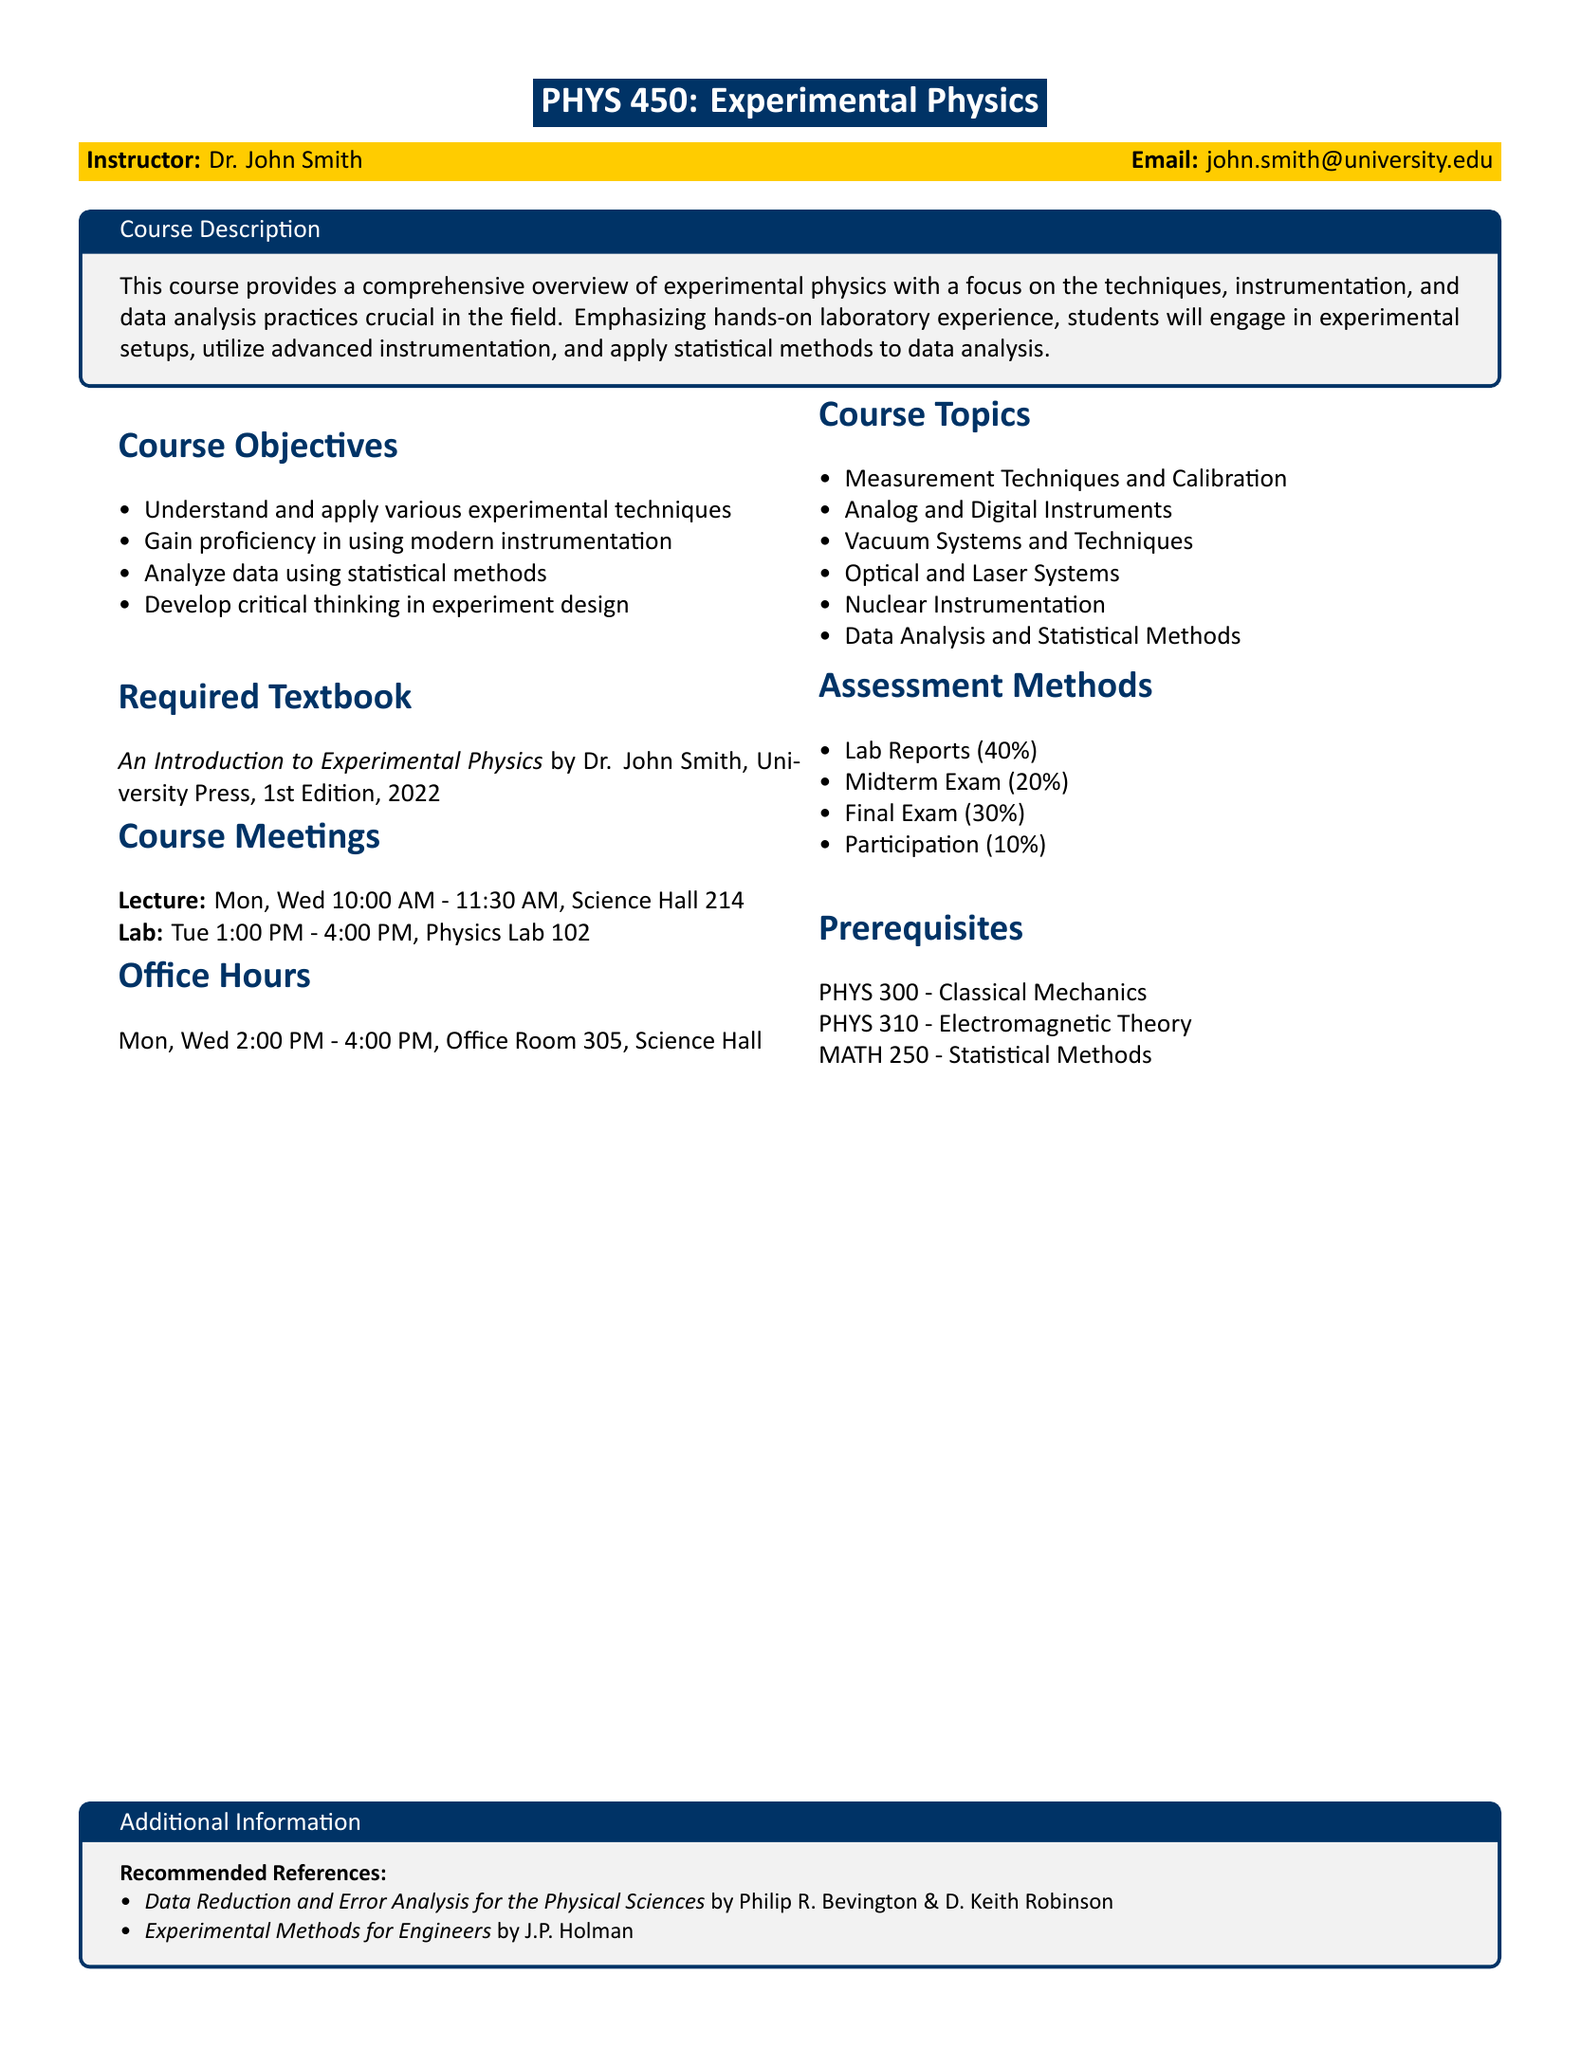What is the course code for Experimental Physics? The course code is stated at the top of the syllabus.
Answer: PHYS 450 Who is the instructor for the course? The instructor's name is provided in the syllabus.
Answer: Dr. John Smith What percentage of the assessment is allocated to lab reports? The distribution of assessment percentages is listed under Assessment Methods.
Answer: 40% On which days and at what time is the lecture scheduled? The schedule for the lecture is provided in the Course Meetings section.
Answer: Mon, Wed 10:00 AM - 11:30 AM What is the title of the required textbook? The name of the required textbook is mentioned in the Required Textbook section.
Answer: An Introduction to Experimental Physics How many hours per week are dedicated to lab sessions? The lab schedule is specified in the Course Meetings section, detailing the hours.
Answer: 3 hours What are the prerequisites for the course? The prerequisites are listed in the relevant section of the syllabus.
Answer: PHYS 300, PHYS 310, MATH 250 What is one of the recommended references for the course? The additional information section offers references for further reading.
Answer: Data Reduction and Error Analysis for the Physical Sciences What is the main focus of the course? The course description highlights what students will learn and engage in throughout the course.
Answer: Techniques, instrumentation, and data analysis practices 